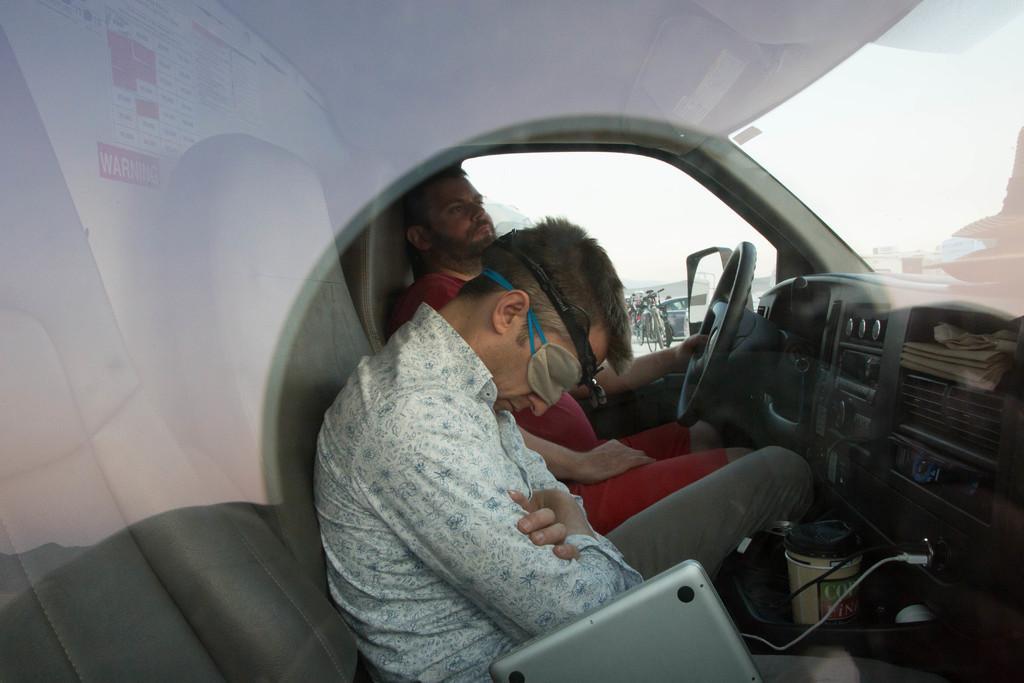How would you summarize this image in a sentence or two? In this picture we can see an inside of a vehicle, here we can see people and in the background we can see sky and some objects. 